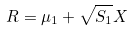<formula> <loc_0><loc_0><loc_500><loc_500>R = \mu _ { 1 } + \sqrt { S _ { 1 } } X</formula> 